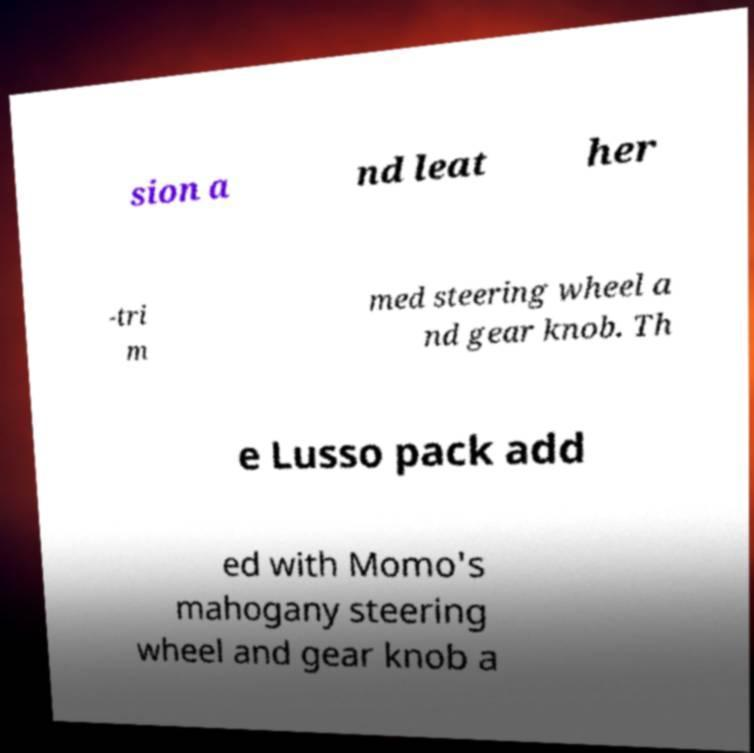There's text embedded in this image that I need extracted. Can you transcribe it verbatim? sion a nd leat her -tri m med steering wheel a nd gear knob. Th e Lusso pack add ed with Momo's mahogany steering wheel and gear knob a 